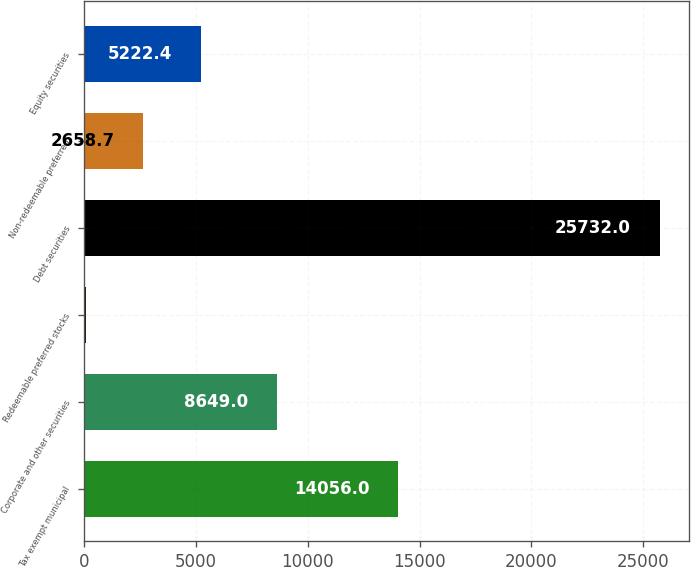Convert chart to OTSL. <chart><loc_0><loc_0><loc_500><loc_500><bar_chart><fcel>Tax exempt municipal<fcel>Corporate and other securities<fcel>Redeemable preferred stocks<fcel>Debt securities<fcel>Non-redeemable preferred<fcel>Equity securities<nl><fcel>14056<fcel>8649<fcel>95<fcel>25732<fcel>2658.7<fcel>5222.4<nl></chart> 